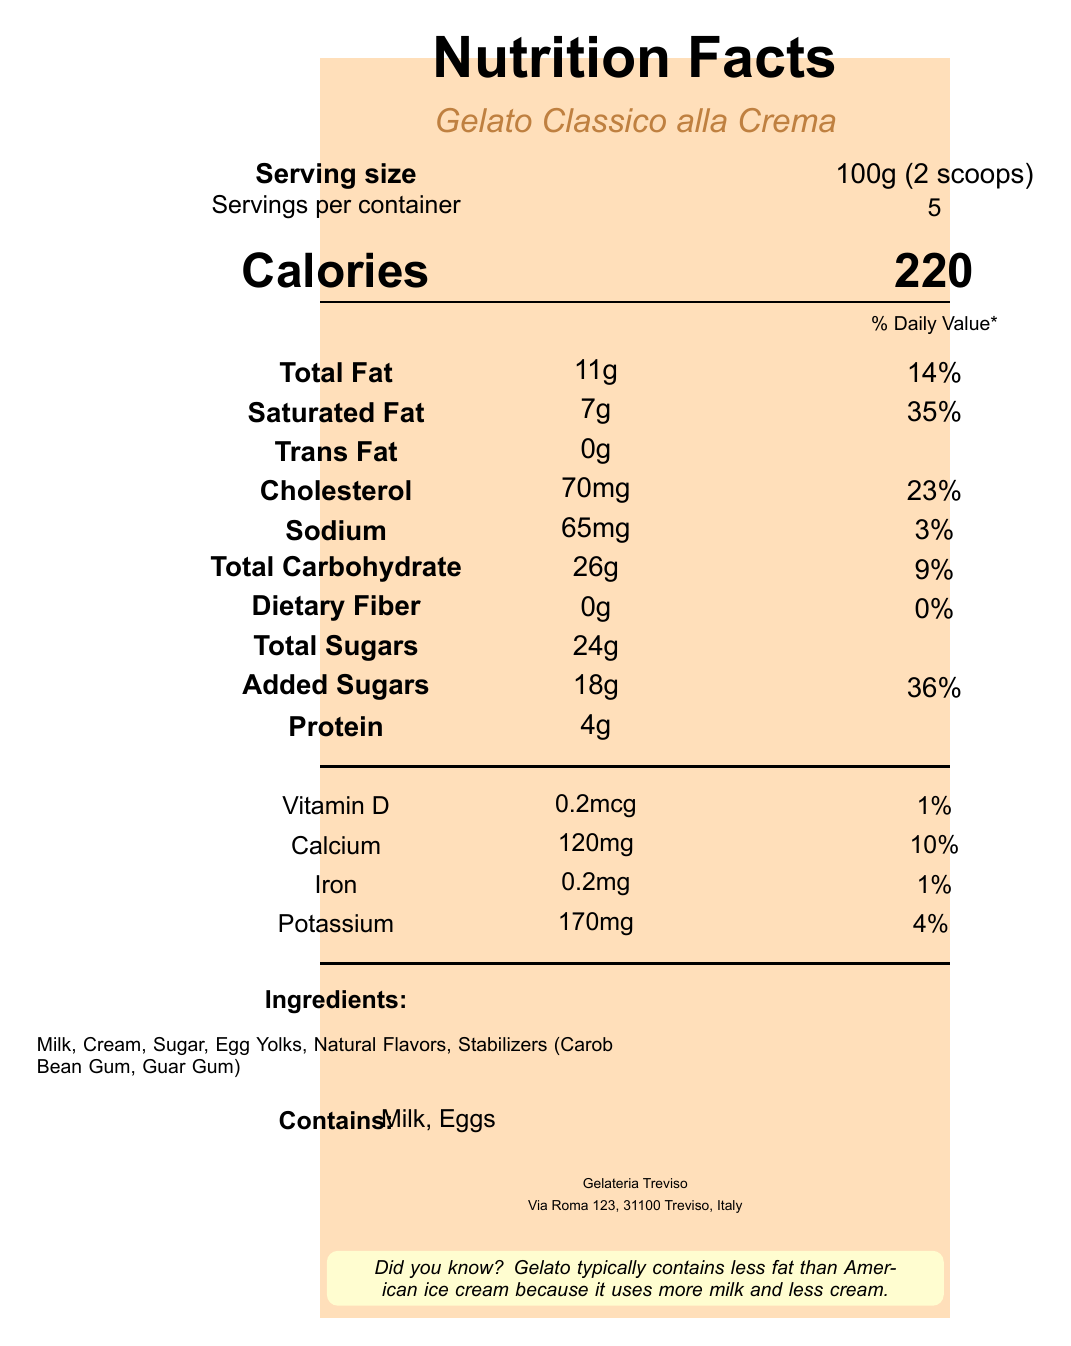what is the serving size of Gelato Classico alla Crema? The serving size is clearly mentioned under the serving information section of the label.
Answer: 100g (2 scoops) how many servings per container are there? The number of servings per container is listed right below the serving size section.
Answer: 5 how many calories are there per serving? The calorie count per serving is provided in the central part of the label in a larger font size.
Answer: 220 how much total fat is in one serving? The total fat content is listed under the nutritional information section as "Total Fat."
Answer: 11g what percent of the daily value is the saturated fat content? The percent daily value of saturated fat is mentioned next to the amount of saturated fat in the nutritional information section.
Answer: 35% how much cholesterol does one serving contain? The cholesterol content per serving is indicated in the nutritional facts.
Answer: 70mg how much sodium is in one serving? The sodium amount per serving is listed under the nutritional information section.
Answer: 65mg how much protein is in one serving? The protein content can be found in the nutritional information part of the label.
Answer: 4g what are the ingredients in Gelato Classico alla Crema? The ingredients are enumerated in the ingredients section near the bottom of the label.
Answer: Milk, Cream, Sugar, Egg Yolks, Natural Flavors, Stabilizers (Carob Bean Gum, Guar Gum) What is the main idea of the document? The document summarized contains detailed nutritional information, ingredients, servings, and manufacturing details of Gelato Classico alla Crema.
Answer: It provides the nutrition facts of Gelato Classico alla Crema, including serving size, calories, fats, and other nutritional information as well as ingredients and allergen details. how many grams of dietary fiber is in one serving? The dietary fiber content is stated clearly in the nutritional information section.
Answer: 0g which of the following contains the highest percent daily value? A. Total Fat B. Saturated Fat C. Cholesterol D. Sodium Saturated Fat has the highest percent daily value at 35%.
Answer: B. Saturated Fat what is the amount of calcium in one serving? A. 65mg B. 120mg C. 170mg D. 0.2mcg The Calcium content is provided as 120mg in the vitamins and minerals section.
Answer: B. 120mg does Gelato Classico alla Crema contain any trans fat? The document specifies the amount of trans fat as 0g, which means there is no trans fat.
Answer: No How much potassium is in one serving? The potassium content is listed in the vitamins and minerals section.
Answer: 170mg Based on the document, where is the manufacturer located? The manufacturer information is given at the bottom of the document.
Answer: Via Roma 123, 31100 Treviso, Italy what is the daily value of total sugars in one serving? The document does not provide the daily value percent for total sugars.
Answer: Cannot be determined can you name one fact mentioned in the fun fact section? The fun fact section mentions this specific fact about gelato compared to American ice cream.
Answer: Gelato typically contains less fat than American ice cream because it uses more milk and less cream. 